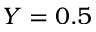<formula> <loc_0><loc_0><loc_500><loc_500>Y = 0 . 5</formula> 